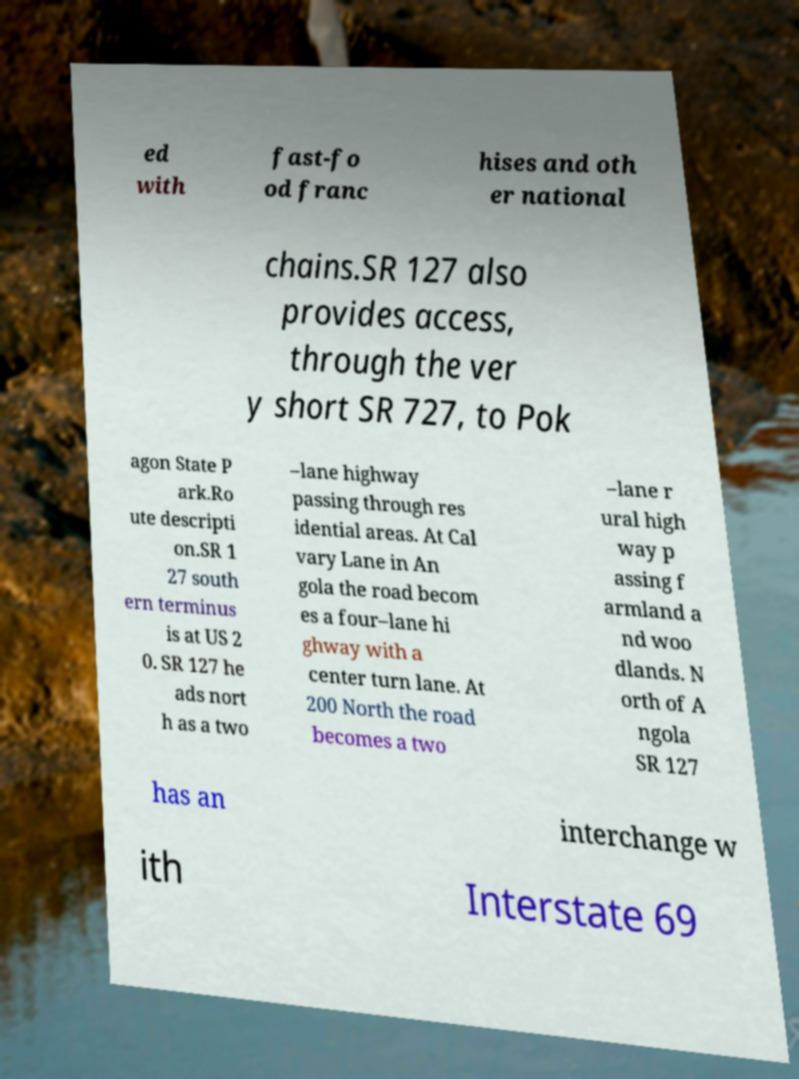Can you read and provide the text displayed in the image?This photo seems to have some interesting text. Can you extract and type it out for me? ed with fast-fo od franc hises and oth er national chains.SR 127 also provides access, through the ver y short SR 727, to Pok agon State P ark.Ro ute descripti on.SR 1 27 south ern terminus is at US 2 0. SR 127 he ads nort h as a two –lane highway passing through res idential areas. At Cal vary Lane in An gola the road becom es a four–lane hi ghway with a center turn lane. At 200 North the road becomes a two –lane r ural high way p assing f armland a nd woo dlands. N orth of A ngola SR 127 has an interchange w ith Interstate 69 